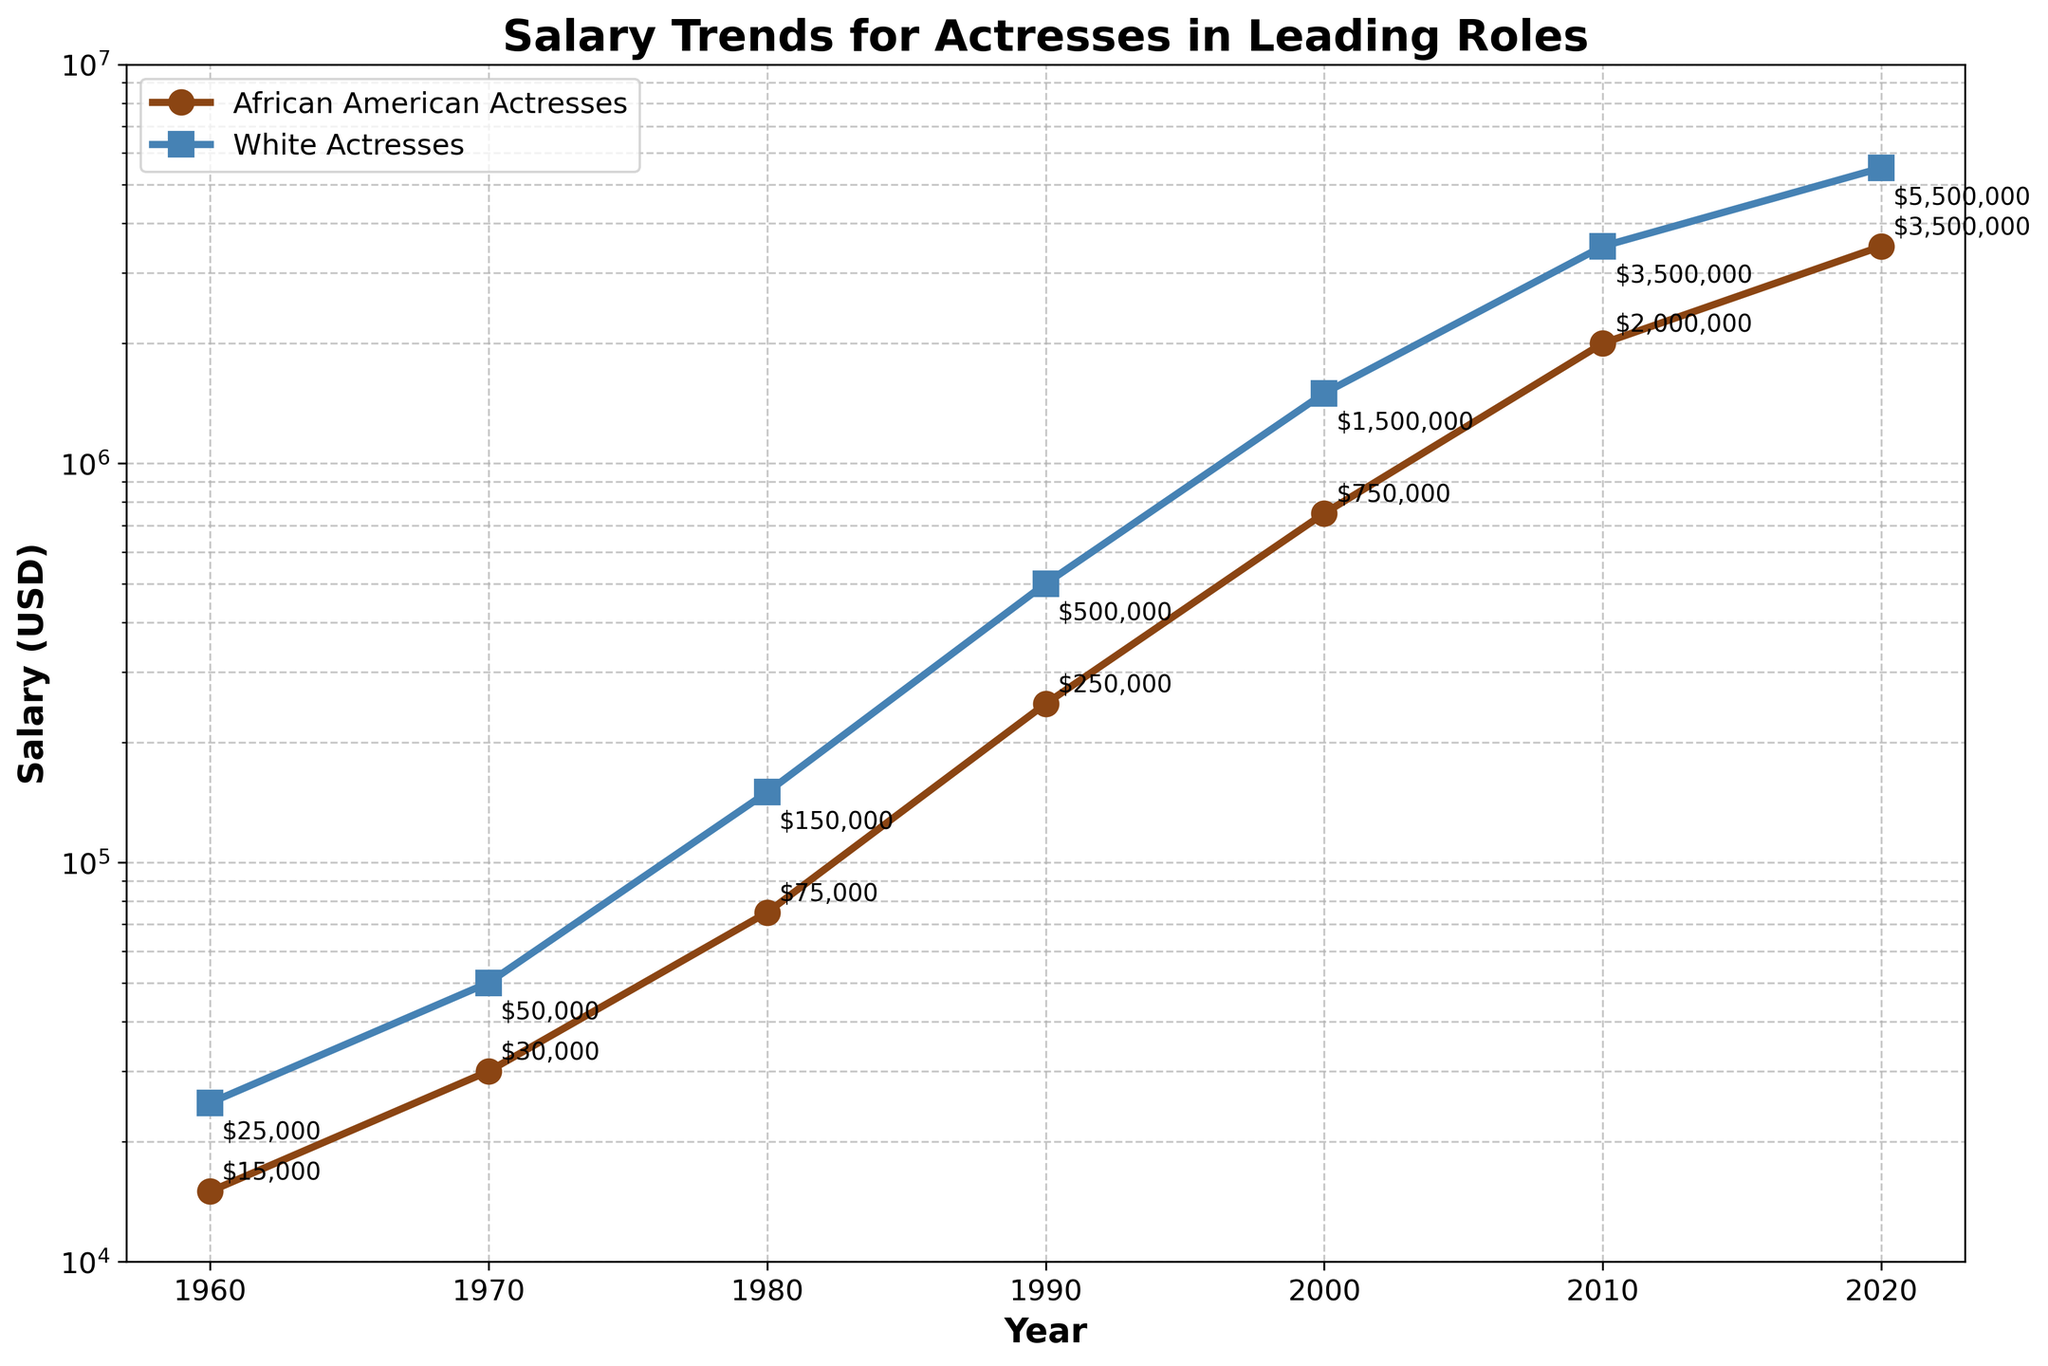What is the difference in salary between African American actresses and White actresses in 1980? Look at the data points on the graph for the year 1980. The salary for African American actresses is $75,000, and for White actresses, it is $150,000. The difference is $150,000 - $75,000 = $75,000.
Answer: $75,000 Which group had a higher salary growth from 1960 to 2020? Calculate the salary growth for each group by subtracting the 1960 value from the 2020 value. For African American actresses: $3,500,000 - $15,000 = $3,485,000. For White actresses: $5,500,000 - $25,000 = $5,475,000. Compare these growths: $5,475,000 > $3,485,000.
Answer: White actresses What is the average salary of African American actresses and White actresses in 2020? The salary of African American actresses in 2020 is $3,500,000, and for White actresses, it is $5,500,000. The average is ($3,500,000 + $5,500,000) / 2 = $4,500,000.
Answer: $4,500,000 Which year shows the highest salary ratio between White actresses and African American actresses? To find the ratio for each year, divide the salary of White actresses by the salary of African American actresses. Highest ratio: 1960: $25,000 / $15,000 = 1.67; 1970: $50,000 / $30,000 = 1.67; 1980: $150,000 / $75,000 = 2; 1990: $500,000 / $250,000 = 2; 2000: $1,500,000 / $750,000 = 2; 2010: $3,500,000 / $2,000,000 = 1.75; 2020: $5,500,000 / $3,500,000 = 1.57. Highest ratio is in 1980, 1990, and 2000 with a ratio of 2.
Answer: 1980, 1990, and 2000 Identify the year in which African American actresses' salaries reached $750,000. On the graph, look for the year where the salary of African American actresses reaches $750,000. This occurs in the year 2000.
Answer: 2000 What is the trend of salary growth for both groups from 1960 to 2020? Observe the lines plotted for both groups from 1960 to 2020. Both trends show a consistent increase. Salaries for both African American and White actresses increase over time.
Answer: Increasing trend How much did the salary of African American actresses increase from 1970 to 1980? Use the data points for 1970 and 1980. Salary in 1970 is $30,000, and in 1980 it is $75,000. The increase is $75,000 - $30,000 = $45,000.
Answer: $45,000 By what factor did the salary of White actresses grow from 2000 to 2010? Using the graph, the salary in 2000 is $1,500,000, and in 2010, it is $3,500,000. The factor is $3,500,000 / $1,500,000 = 2.33.
Answer: 2.33 What was the difference in salaries in 2010 between the two groups? Refer to 2010 on the graph. African American actresses: $2,000,000. White actresses: $3,500,000. Difference: $3,500,000 - $2,000,000 = $1,500,000.
Answer: $1,500,000 At which years do the salaries of African American actresses show the most significant jumps? Identify where the graph line for African American actresses has the steepest increases. Significant jumps occur between 1970 ($30,000) to 1980 ($75,000), 1980 to 1990 ($250,000), and 2000 to 2010 ($2,000,000).
Answer: 1970-1980, 1980-1990, 2000-2010 